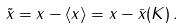<formula> <loc_0><loc_0><loc_500><loc_500>\tilde { x } = x - \langle x \rangle = x - \bar { x } ( K ) \, .</formula> 